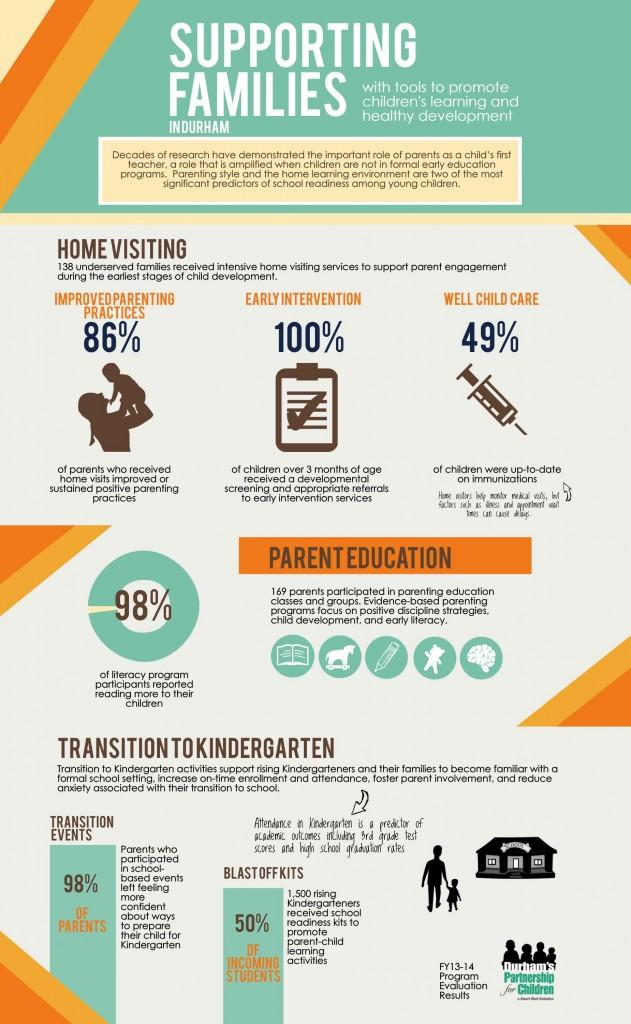List a handful of essential elements in this visual. According to the data, only 14% of parents have reportedly improved their parenting practices. According to the data, 51% of children were not up-to-date on their immunizations. 